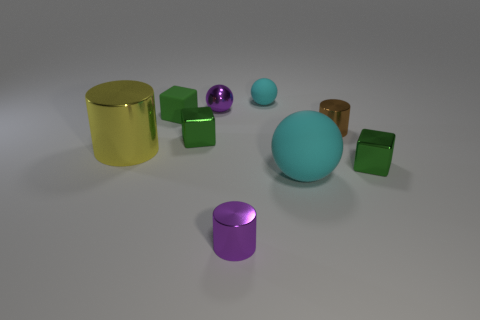There is a cyan rubber object that is in front of the yellow shiny thing; what is its shape?
Ensure brevity in your answer.  Sphere. Is the number of tiny metallic balls less than the number of blue shiny objects?
Your answer should be very brief. No. Are the small green cube that is behind the small brown shiny cylinder and the yellow cylinder made of the same material?
Your response must be concise. No. There is a big cylinder; are there any tiny matte objects behind it?
Provide a short and direct response. Yes. There is a large thing that is left of the cyan rubber sphere in front of the green metallic thing on the right side of the small rubber ball; what is its color?
Keep it short and to the point. Yellow. There is a cyan object that is the same size as the yellow cylinder; what is its shape?
Your answer should be compact. Sphere. Is the number of metal cylinders greater than the number of big blue spheres?
Your answer should be compact. Yes. There is a purple cylinder in front of the large cylinder; is there a brown object behind it?
Offer a very short reply. Yes. What color is the other tiny metal object that is the same shape as the tiny cyan thing?
Your answer should be very brief. Purple. What color is the other ball that is made of the same material as the large cyan sphere?
Give a very brief answer. Cyan. 